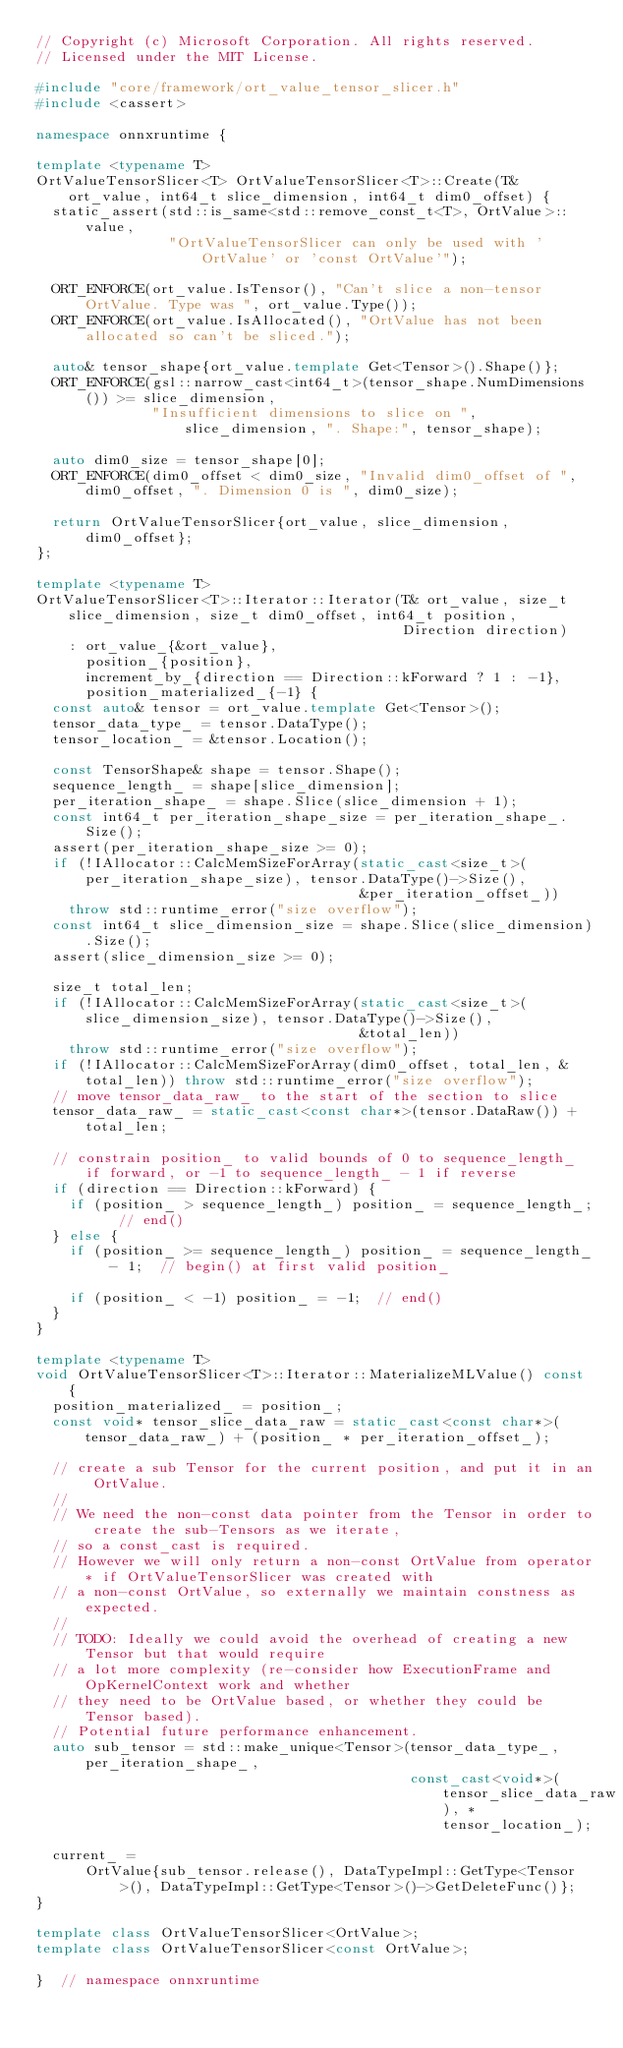Convert code to text. <code><loc_0><loc_0><loc_500><loc_500><_C++_>// Copyright (c) Microsoft Corporation. All rights reserved.
// Licensed under the MIT License.

#include "core/framework/ort_value_tensor_slicer.h"
#include <cassert>

namespace onnxruntime {

template <typename T>
OrtValueTensorSlicer<T> OrtValueTensorSlicer<T>::Create(T& ort_value, int64_t slice_dimension, int64_t dim0_offset) {
  static_assert(std::is_same<std::remove_const_t<T>, OrtValue>::value,
                "OrtValueTensorSlicer can only be used with 'OrtValue' or 'const OrtValue'");

  ORT_ENFORCE(ort_value.IsTensor(), "Can't slice a non-tensor OrtValue. Type was ", ort_value.Type());
  ORT_ENFORCE(ort_value.IsAllocated(), "OrtValue has not been allocated so can't be sliced.");

  auto& tensor_shape{ort_value.template Get<Tensor>().Shape()};
  ORT_ENFORCE(gsl::narrow_cast<int64_t>(tensor_shape.NumDimensions()) >= slice_dimension,
              "Insufficient dimensions to slice on ", slice_dimension, ". Shape:", tensor_shape);

  auto dim0_size = tensor_shape[0];
  ORT_ENFORCE(dim0_offset < dim0_size, "Invalid dim0_offset of ", dim0_offset, ". Dimension 0 is ", dim0_size);

  return OrtValueTensorSlicer{ort_value, slice_dimension, dim0_offset};
};

template <typename T>
OrtValueTensorSlicer<T>::Iterator::Iterator(T& ort_value, size_t slice_dimension, size_t dim0_offset, int64_t position,
                                            Direction direction)
    : ort_value_{&ort_value},
      position_{position},
      increment_by_{direction == Direction::kForward ? 1 : -1},
      position_materialized_{-1} {
  const auto& tensor = ort_value.template Get<Tensor>();
  tensor_data_type_ = tensor.DataType();
  tensor_location_ = &tensor.Location();

  const TensorShape& shape = tensor.Shape();
  sequence_length_ = shape[slice_dimension];
  per_iteration_shape_ = shape.Slice(slice_dimension + 1);
  const int64_t per_iteration_shape_size = per_iteration_shape_.Size();
  assert(per_iteration_shape_size >= 0);
  if (!IAllocator::CalcMemSizeForArray(static_cast<size_t>(per_iteration_shape_size), tensor.DataType()->Size(),
                                       &per_iteration_offset_))
    throw std::runtime_error("size overflow");
  const int64_t slice_dimension_size = shape.Slice(slice_dimension).Size();
  assert(slice_dimension_size >= 0);

  size_t total_len;
  if (!IAllocator::CalcMemSizeForArray(static_cast<size_t>(slice_dimension_size), tensor.DataType()->Size(),
                                       &total_len))
    throw std::runtime_error("size overflow");
  if (!IAllocator::CalcMemSizeForArray(dim0_offset, total_len, &total_len)) throw std::runtime_error("size overflow");
  // move tensor_data_raw_ to the start of the section to slice
  tensor_data_raw_ = static_cast<const char*>(tensor.DataRaw()) + total_len;

  // constrain position_ to valid bounds of 0 to sequence_length_ if forward, or -1 to sequence_length_ - 1 if reverse
  if (direction == Direction::kForward) {
    if (position_ > sequence_length_) position_ = sequence_length_;  // end()
  } else {
    if (position_ >= sequence_length_) position_ = sequence_length_ - 1;  // begin() at first valid position_

    if (position_ < -1) position_ = -1;  // end()
  }
}

template <typename T>
void OrtValueTensorSlicer<T>::Iterator::MaterializeMLValue() const {
  position_materialized_ = position_;
  const void* tensor_slice_data_raw = static_cast<const char*>(tensor_data_raw_) + (position_ * per_iteration_offset_);

  // create a sub Tensor for the current position, and put it in an OrtValue.
  //
  // We need the non-const data pointer from the Tensor in order to create the sub-Tensors as we iterate,
  // so a const_cast is required.
  // However we will only return a non-const OrtValue from operator* if OrtValueTensorSlicer was created with
  // a non-const OrtValue, so externally we maintain constness as expected.
  //
  // TODO: Ideally we could avoid the overhead of creating a new Tensor but that would require
  // a lot more complexity (re-consider how ExecutionFrame and OpKernelContext work and whether
  // they need to be OrtValue based, or whether they could be Tensor based).
  // Potential future performance enhancement.
  auto sub_tensor = std::make_unique<Tensor>(tensor_data_type_, per_iteration_shape_,
                                             const_cast<void*>(tensor_slice_data_raw), *tensor_location_);

  current_ =
      OrtValue{sub_tensor.release(), DataTypeImpl::GetType<Tensor>(), DataTypeImpl::GetType<Tensor>()->GetDeleteFunc()};
}

template class OrtValueTensorSlicer<OrtValue>;
template class OrtValueTensorSlicer<const OrtValue>;

}  // namespace onnxruntime
</code> 